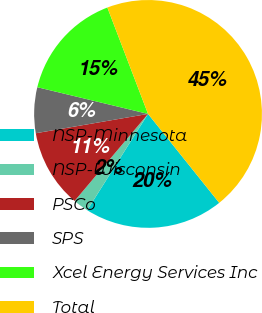Convert chart to OTSL. <chart><loc_0><loc_0><loc_500><loc_500><pie_chart><fcel>NSP-Minnesota<fcel>NSP-Wisconsin<fcel>PSCo<fcel>SPS<fcel>Xcel Energy Services Inc<fcel>Total<nl><fcel>19.71%<fcel>2.19%<fcel>11.13%<fcel>6.48%<fcel>15.42%<fcel>45.07%<nl></chart> 